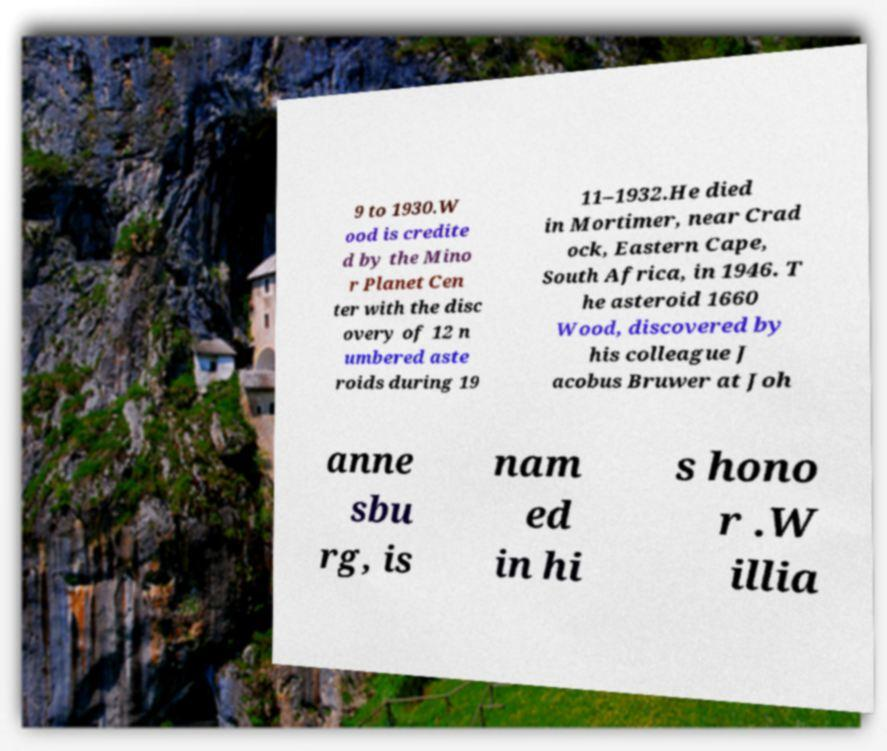I need the written content from this picture converted into text. Can you do that? 9 to 1930.W ood is credite d by the Mino r Planet Cen ter with the disc overy of 12 n umbered aste roids during 19 11–1932.He died in Mortimer, near Crad ock, Eastern Cape, South Africa, in 1946. T he asteroid 1660 Wood, discovered by his colleague J acobus Bruwer at Joh anne sbu rg, is nam ed in hi s hono r .W illia 